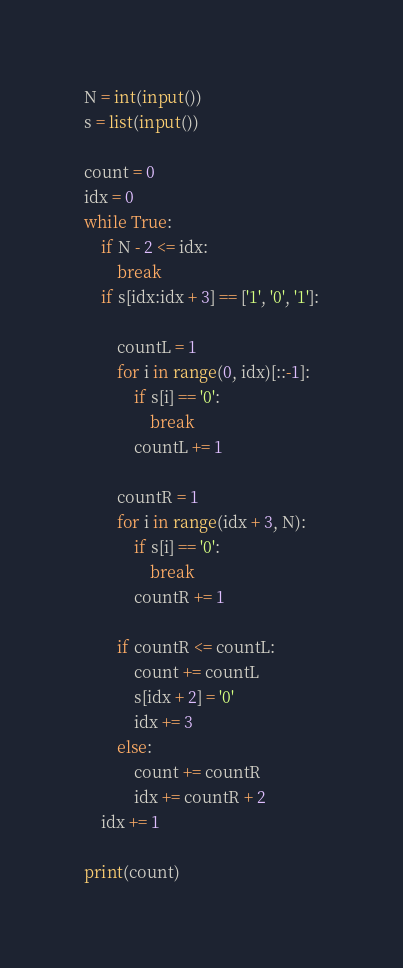<code> <loc_0><loc_0><loc_500><loc_500><_Python_>N = int(input())
s = list(input())

count = 0
idx = 0
while True:
    if N - 2 <= idx:
        break
    if s[idx:idx + 3] == ['1', '0', '1']:

        countL = 1
        for i in range(0, idx)[::-1]:
            if s[i] == '0':
                break
            countL += 1

        countR = 1
        for i in range(idx + 3, N):
            if s[i] == '0':
                break
            countR += 1

        if countR <= countL:
            count += countL
            s[idx + 2] = '0'
            idx += 3
        else:
            count += countR
            idx += countR + 2
    idx += 1

print(count)</code> 